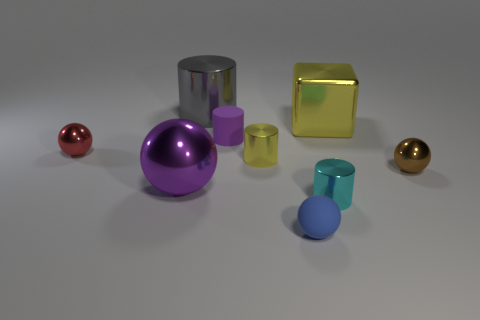There is a blue matte object that is to the right of the purple matte cylinder; is its size the same as the large gray object? no 